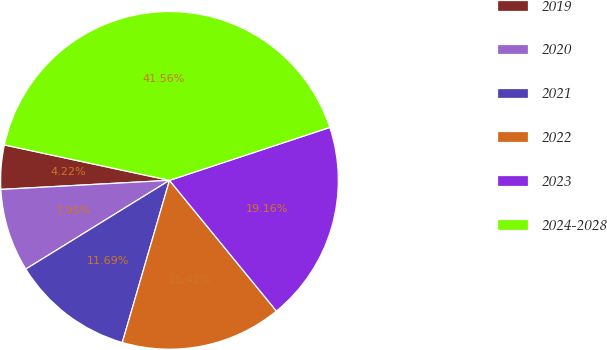Convert chart to OTSL. <chart><loc_0><loc_0><loc_500><loc_500><pie_chart><fcel>2019<fcel>2020<fcel>2021<fcel>2022<fcel>2023<fcel>2024-2028<nl><fcel>4.22%<fcel>7.95%<fcel>11.69%<fcel>15.42%<fcel>19.16%<fcel>41.56%<nl></chart> 